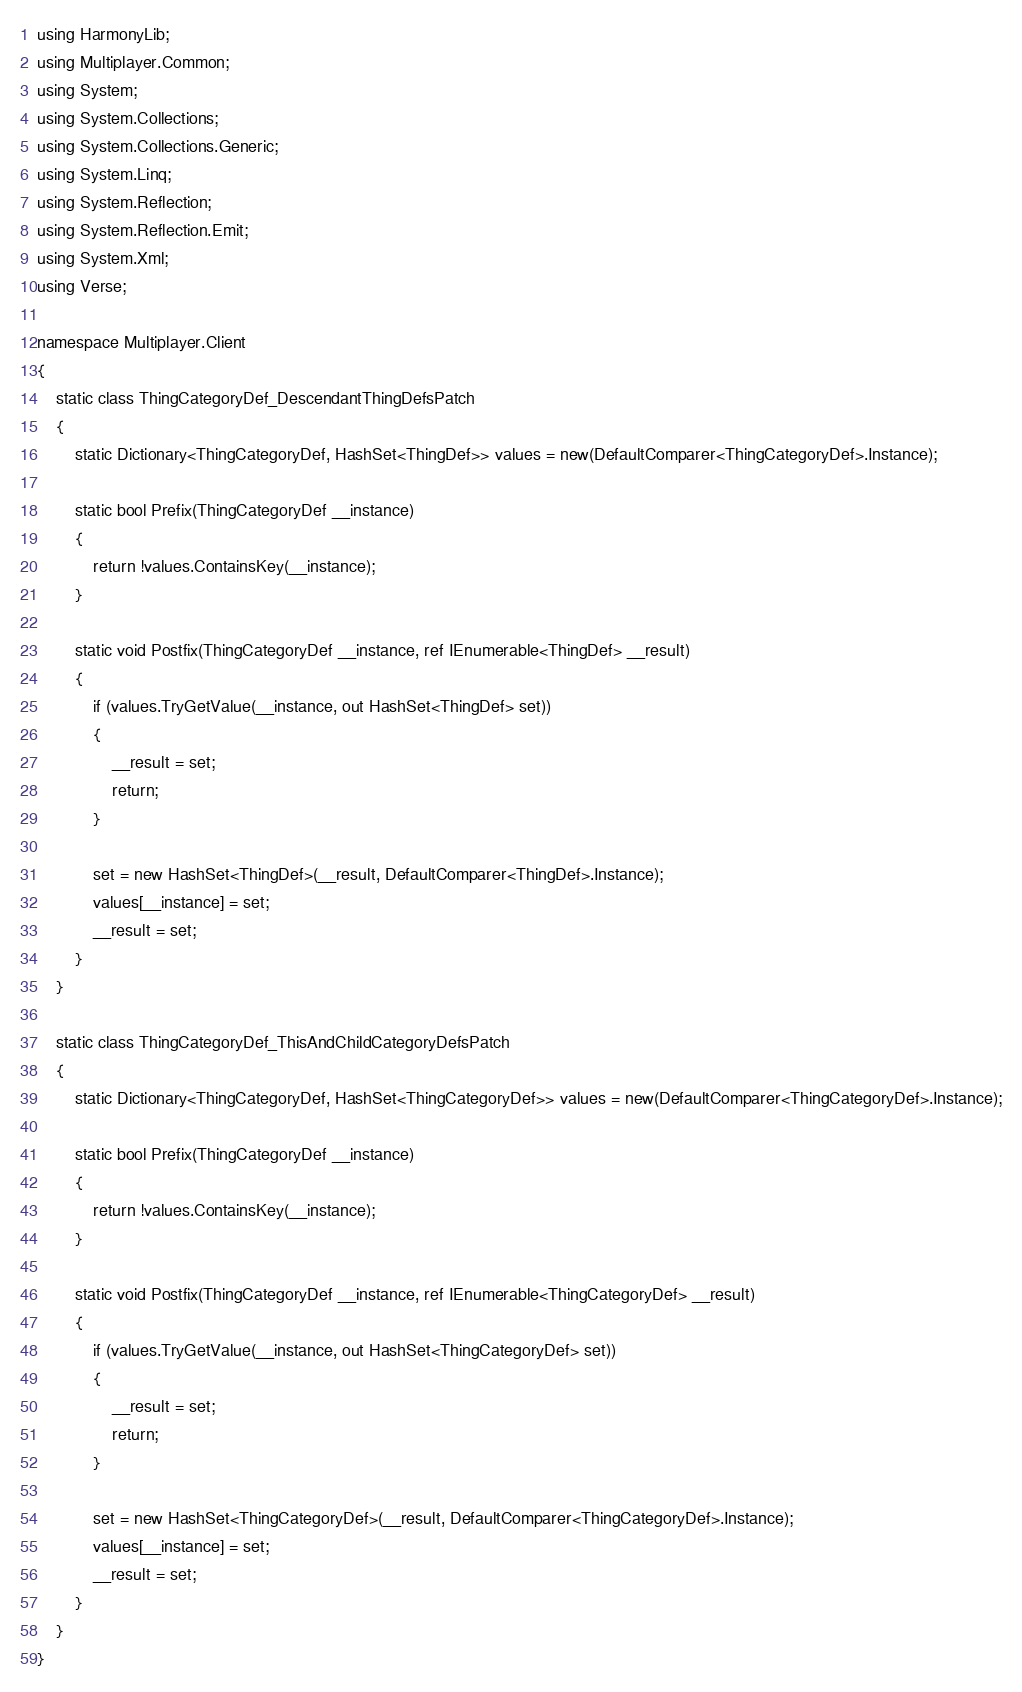Convert code to text. <code><loc_0><loc_0><loc_500><loc_500><_C#_>using HarmonyLib;
using Multiplayer.Common;
using System;
using System.Collections;
using System.Collections.Generic;
using System.Linq;
using System.Reflection;
using System.Reflection.Emit;
using System.Xml;
using Verse;

namespace Multiplayer.Client
{
    static class ThingCategoryDef_DescendantThingDefsPatch
    {
        static Dictionary<ThingCategoryDef, HashSet<ThingDef>> values = new(DefaultComparer<ThingCategoryDef>.Instance);

        static bool Prefix(ThingCategoryDef __instance)
        {
            return !values.ContainsKey(__instance);
        }

        static void Postfix(ThingCategoryDef __instance, ref IEnumerable<ThingDef> __result)
        {
            if (values.TryGetValue(__instance, out HashSet<ThingDef> set))
            {
                __result = set;
                return;
            }

            set = new HashSet<ThingDef>(__result, DefaultComparer<ThingDef>.Instance);
            values[__instance] = set;
            __result = set;
        }
    }

    static class ThingCategoryDef_ThisAndChildCategoryDefsPatch
    {
        static Dictionary<ThingCategoryDef, HashSet<ThingCategoryDef>> values = new(DefaultComparer<ThingCategoryDef>.Instance);

        static bool Prefix(ThingCategoryDef __instance)
        {
            return !values.ContainsKey(__instance);
        }

        static void Postfix(ThingCategoryDef __instance, ref IEnumerable<ThingCategoryDef> __result)
        {
            if (values.TryGetValue(__instance, out HashSet<ThingCategoryDef> set))
            {
                __result = set;
                return;
            }

            set = new HashSet<ThingCategoryDef>(__result, DefaultComparer<ThingCategoryDef>.Instance);
            values[__instance] = set;
            __result = set;
        }
    }
}
</code> 